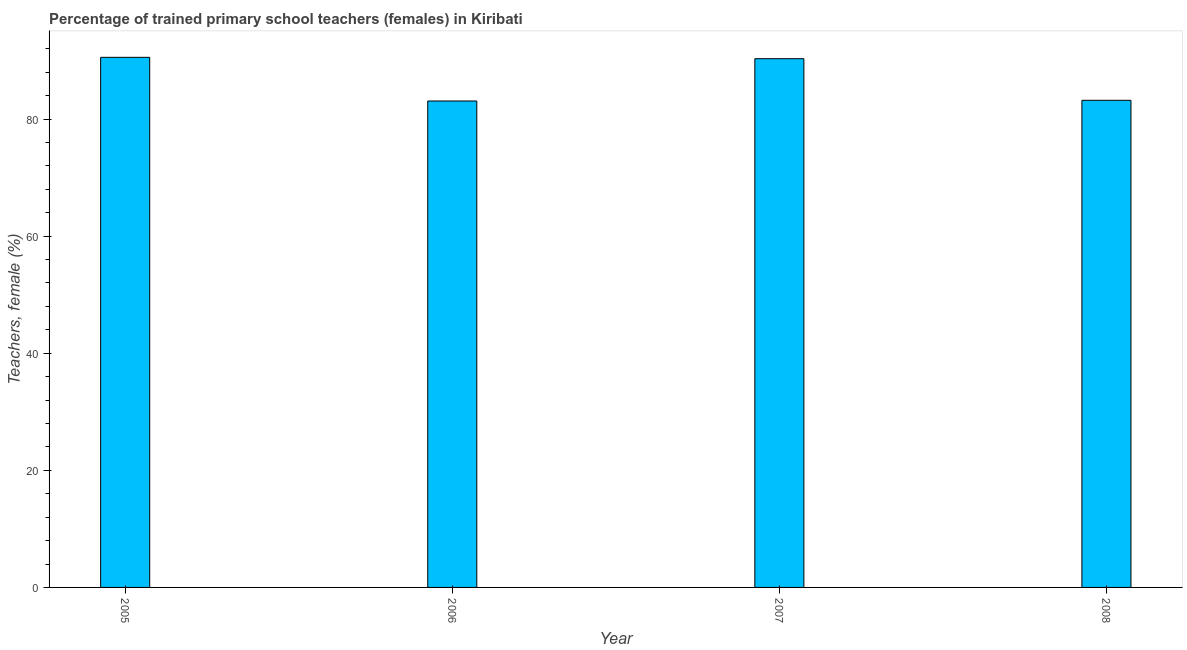Does the graph contain grids?
Your answer should be very brief. No. What is the title of the graph?
Keep it short and to the point. Percentage of trained primary school teachers (females) in Kiribati. What is the label or title of the Y-axis?
Keep it short and to the point. Teachers, female (%). What is the percentage of trained female teachers in 2005?
Make the answer very short. 90.53. Across all years, what is the maximum percentage of trained female teachers?
Your answer should be very brief. 90.53. Across all years, what is the minimum percentage of trained female teachers?
Keep it short and to the point. 83.08. In which year was the percentage of trained female teachers minimum?
Make the answer very short. 2006. What is the sum of the percentage of trained female teachers?
Your response must be concise. 347.1. What is the difference between the percentage of trained female teachers in 2005 and 2007?
Your answer should be very brief. 0.23. What is the average percentage of trained female teachers per year?
Your response must be concise. 86.78. What is the median percentage of trained female teachers?
Offer a terse response. 86.75. In how many years, is the percentage of trained female teachers greater than 36 %?
Offer a very short reply. 4. Do a majority of the years between 2006 and 2007 (inclusive) have percentage of trained female teachers greater than 32 %?
Offer a terse response. Yes. What is the ratio of the percentage of trained female teachers in 2005 to that in 2006?
Your response must be concise. 1.09. What is the difference between the highest and the second highest percentage of trained female teachers?
Your answer should be very brief. 0.23. What is the difference between the highest and the lowest percentage of trained female teachers?
Provide a short and direct response. 7.46. In how many years, is the percentage of trained female teachers greater than the average percentage of trained female teachers taken over all years?
Keep it short and to the point. 2. Are all the bars in the graph horizontal?
Offer a terse response. No. What is the difference between two consecutive major ticks on the Y-axis?
Your answer should be very brief. 20. What is the Teachers, female (%) of 2005?
Provide a succinct answer. 90.53. What is the Teachers, female (%) in 2006?
Provide a short and direct response. 83.08. What is the Teachers, female (%) in 2007?
Your response must be concise. 90.3. What is the Teachers, female (%) of 2008?
Provide a succinct answer. 83.19. What is the difference between the Teachers, female (%) in 2005 and 2006?
Make the answer very short. 7.46. What is the difference between the Teachers, female (%) in 2005 and 2007?
Give a very brief answer. 0.23. What is the difference between the Teachers, female (%) in 2005 and 2008?
Make the answer very short. 7.34. What is the difference between the Teachers, female (%) in 2006 and 2007?
Offer a terse response. -7.22. What is the difference between the Teachers, female (%) in 2006 and 2008?
Make the answer very short. -0.12. What is the difference between the Teachers, female (%) in 2007 and 2008?
Give a very brief answer. 7.11. What is the ratio of the Teachers, female (%) in 2005 to that in 2006?
Your answer should be compact. 1.09. What is the ratio of the Teachers, female (%) in 2005 to that in 2008?
Give a very brief answer. 1.09. What is the ratio of the Teachers, female (%) in 2006 to that in 2008?
Keep it short and to the point. 1. What is the ratio of the Teachers, female (%) in 2007 to that in 2008?
Ensure brevity in your answer.  1.08. 